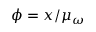<formula> <loc_0><loc_0><loc_500><loc_500>\phi = x / \mu _ { \omega }</formula> 